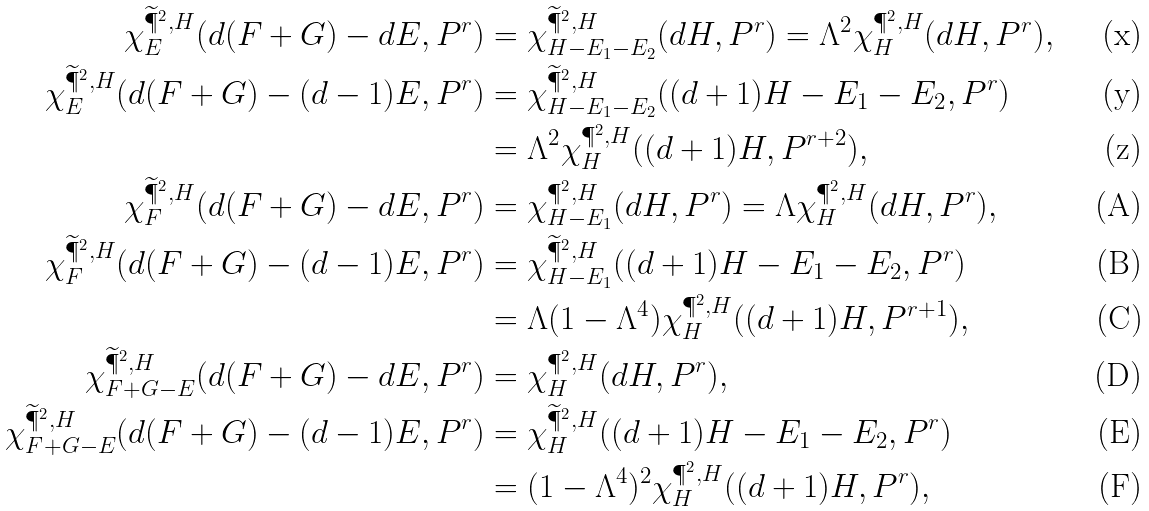<formula> <loc_0><loc_0><loc_500><loc_500>\chi ^ { \widetilde { \P } ^ { 2 } , H } _ { E } ( d ( F + G ) - d E , P ^ { r } ) & = \chi ^ { \widetilde { \P } ^ { 2 } , H } _ { H - E _ { 1 } - E _ { 2 } } ( d H , P ^ { r } ) = \Lambda ^ { 2 } \chi ^ { \P ^ { 2 } , H } _ { H } ( d H , P ^ { r } ) , \\ \chi ^ { \widetilde { \P } ^ { 2 } , H } _ { E } ( d ( F + G ) - ( d - 1 ) E , P ^ { r } ) & = \chi ^ { \widetilde { \P } ^ { 2 } , H } _ { H - E _ { 1 } - E _ { 2 } } ( ( d + 1 ) H - E _ { 1 } - E _ { 2 } , P ^ { r } ) \\ & = \Lambda ^ { 2 } \chi ^ { \P ^ { 2 } , H } _ { H } ( ( d + 1 ) H , P ^ { r + 2 } ) , \\ \chi ^ { \widetilde { \P } ^ { 2 } , H } _ { F } ( d ( F + G ) - d E , P ^ { r } ) & = \chi ^ { \P ^ { 2 } , H } _ { H - E _ { 1 } } ( d H , P ^ { r } ) = \Lambda \chi ^ { \P ^ { 2 } , H } _ { H } ( d H , P ^ { r } ) , \\ \chi ^ { \widetilde { \P } ^ { 2 } , H } _ { F } ( d ( F + G ) - ( d - 1 ) E , P ^ { r } ) & = \chi ^ { \widetilde { \P } ^ { 2 } , H } _ { H - E _ { 1 } } ( ( d + 1 ) H - E _ { 1 } - E _ { 2 } , P ^ { r } ) \\ & = \Lambda ( 1 - \Lambda ^ { 4 } ) \chi ^ { \P ^ { 2 } , H } _ { H } ( ( d + 1 ) H , P ^ { r + 1 } ) , \\ \chi ^ { \widetilde { \P } ^ { 2 } , H } _ { F + G - E } ( d ( F + G ) - d E , P ^ { r } ) & = \chi ^ { \P ^ { 2 } , H } _ { H } ( d H , P ^ { r } ) , \\ \chi ^ { \widetilde { \P } ^ { 2 } , H } _ { F + G - E } ( d ( F + G ) - ( d - 1 ) E , P ^ { r } ) & = \chi ^ { \widetilde { \P } ^ { 2 } , H } _ { H } ( ( d + 1 ) H - E _ { 1 } - E _ { 2 } , P ^ { r } ) \\ & = ( 1 - \Lambda ^ { 4 } ) ^ { 2 } \chi ^ { \P ^ { 2 } , H } _ { H } ( ( d + 1 ) H , P ^ { r } ) ,</formula> 